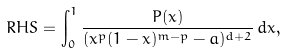Convert formula to latex. <formula><loc_0><loc_0><loc_500><loc_500>R H S = \int _ { 0 } ^ { 1 } \frac { P ( x ) } { ( x ^ { p } ( 1 - x ) ^ { m - p } - a ) ^ { d + 2 } } \, d x ,</formula> 